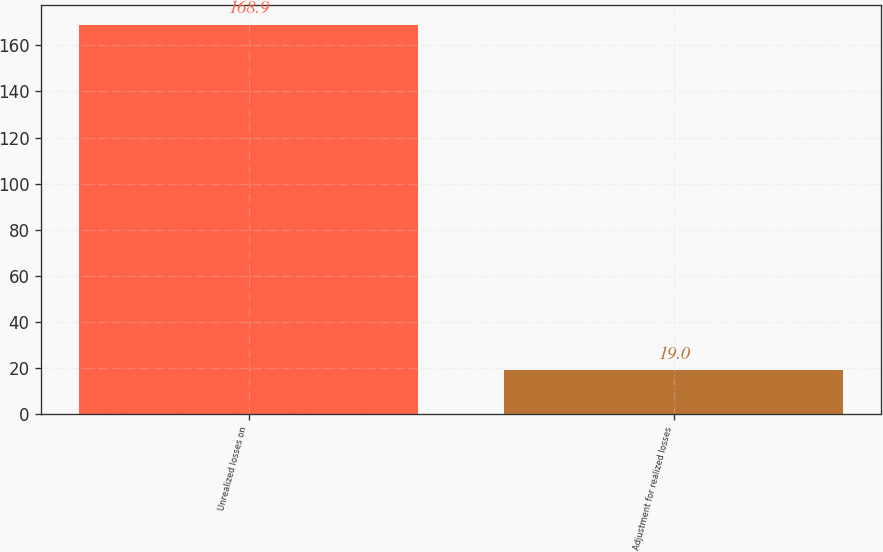<chart> <loc_0><loc_0><loc_500><loc_500><bar_chart><fcel>Unrealized losses on<fcel>Adjustment for realized losses<nl><fcel>168.9<fcel>19<nl></chart> 